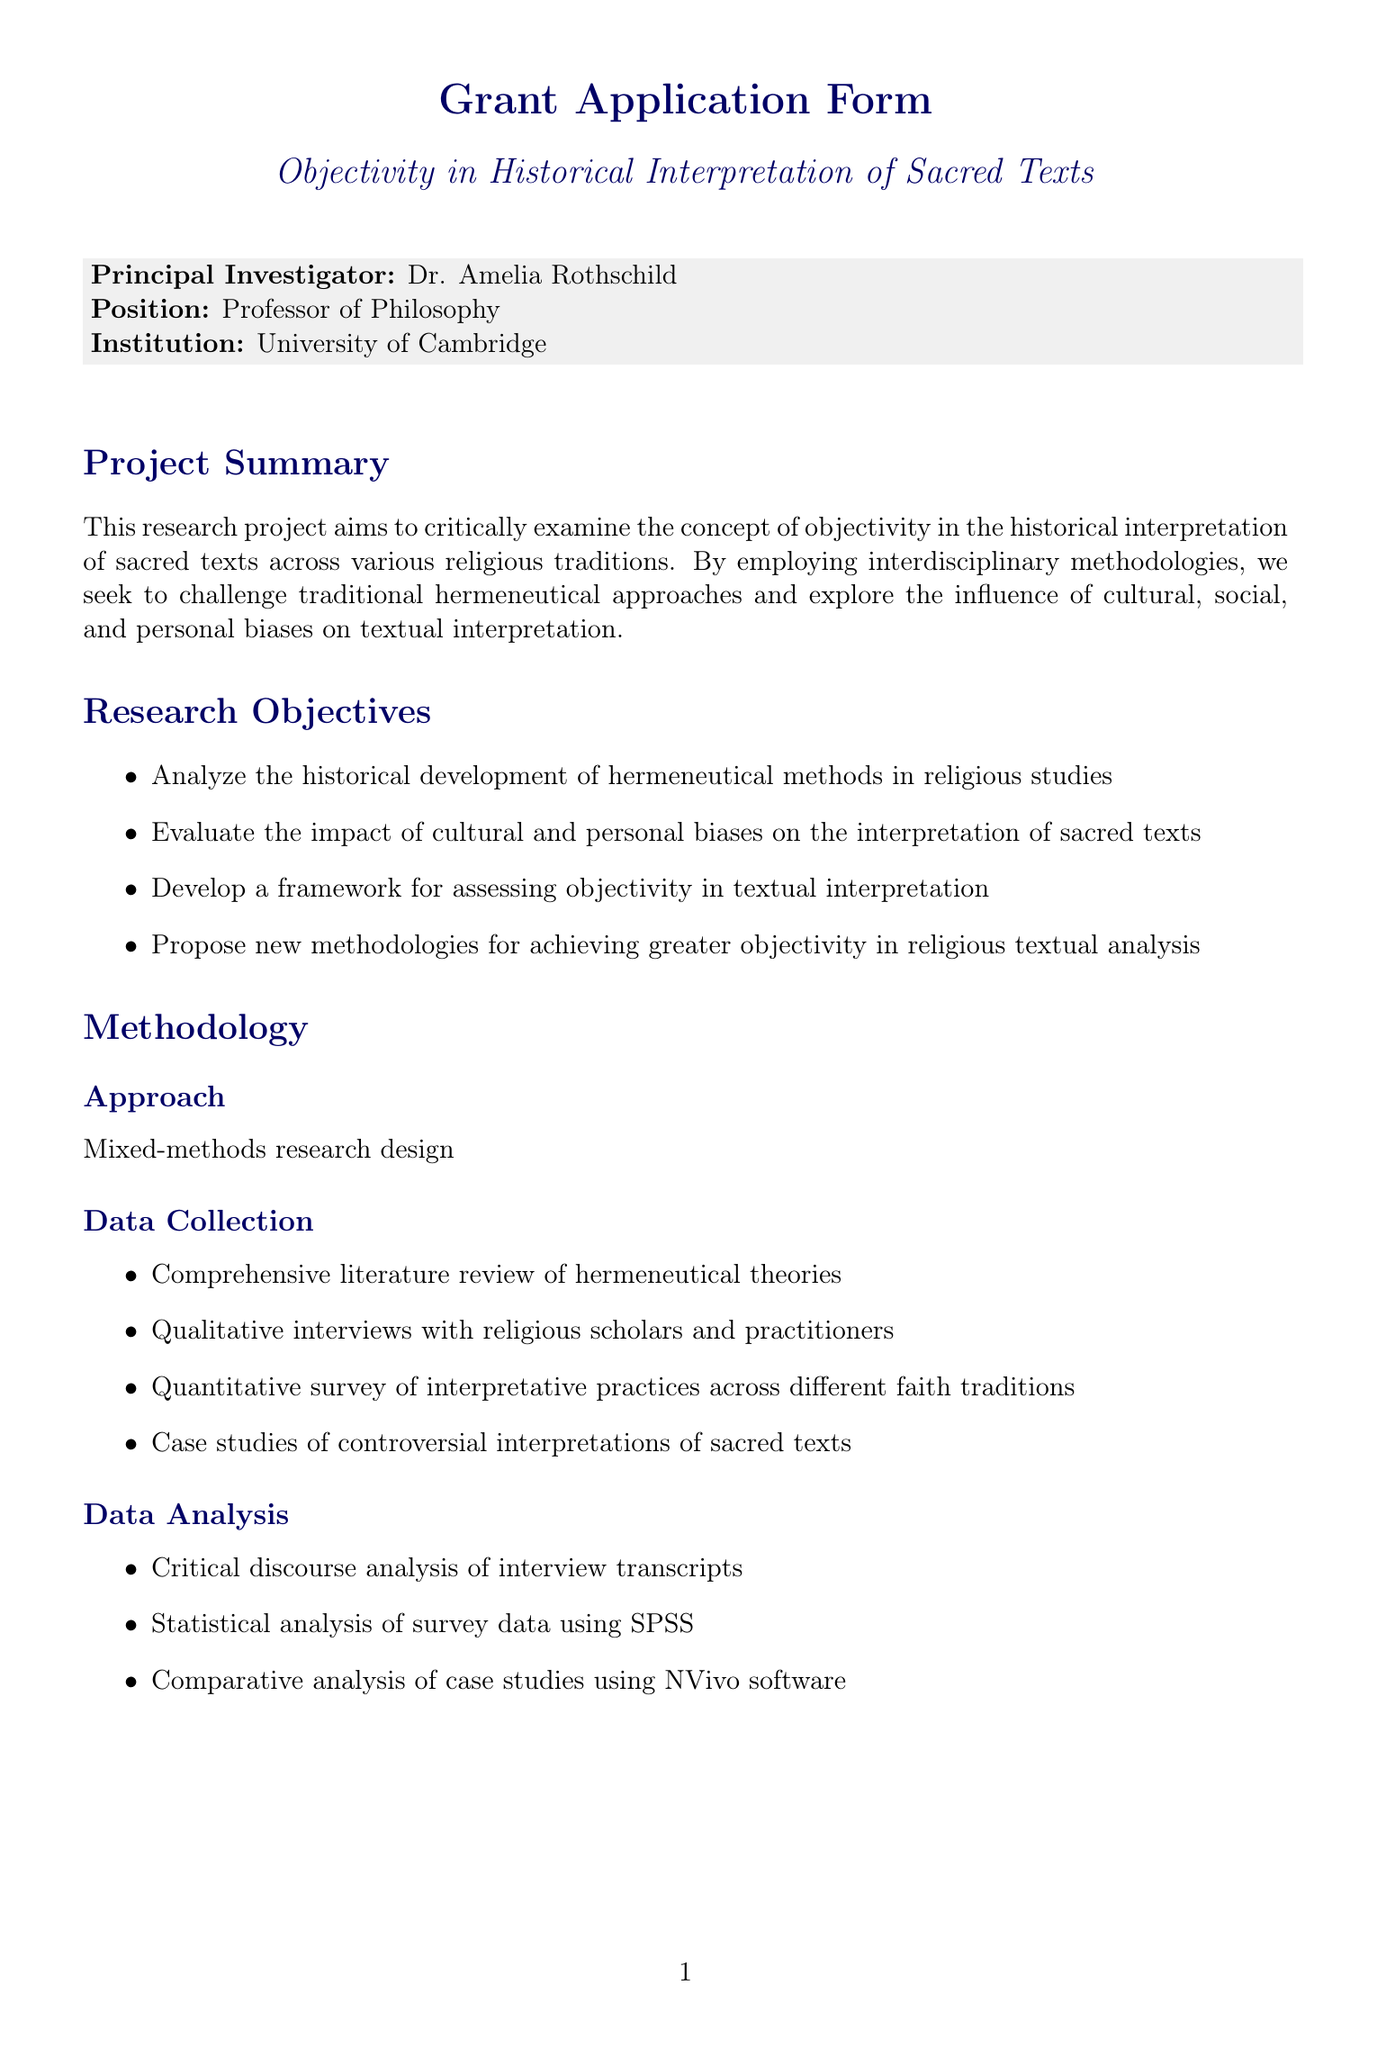What is the project title? The project title is specified at the beginning of the document, indicating the main focus of the research.
Answer: Objectivity in Historical Interpretation of Sacred Texts Who is the principal investigator? The document identifies the individual leading the research project, along with their institutional affiliation.
Answer: Dr. Amelia Rothschild What is the total budget requested? The total budget requested is a key financial figure necessary for the funding of the project.
Answer: 250000 How long is the project duration? The timeline section outlines the duration of the project in months.
Answer: 24 months What methodology will be used for data collection? The methodology section lists various methods for gathering data related to the research project.
Answer: Mixed-methods research design What are the expected outcomes of the project? Expected outcomes summarize the key deliverables and impacts stemming from the research.
Answer: Publication of at least three peer-reviewed articles in high-impact journals Which institution will provide expertise in comparative religion studies? The collaborating institutions section specifies which partner will offer their knowledge for the research project.
Answer: Harvard Divinity School What ethical consideration involves ensuring confidentiality? The ethical considerations section describes practices to protect the participants involved in the research.
Answer: Ensure confidentiality and anonymity of interviewees What is the amount allocated for participant compensation? The budget breakdown includes financial details for compensating those involved in the research process.
Answer: 20000 